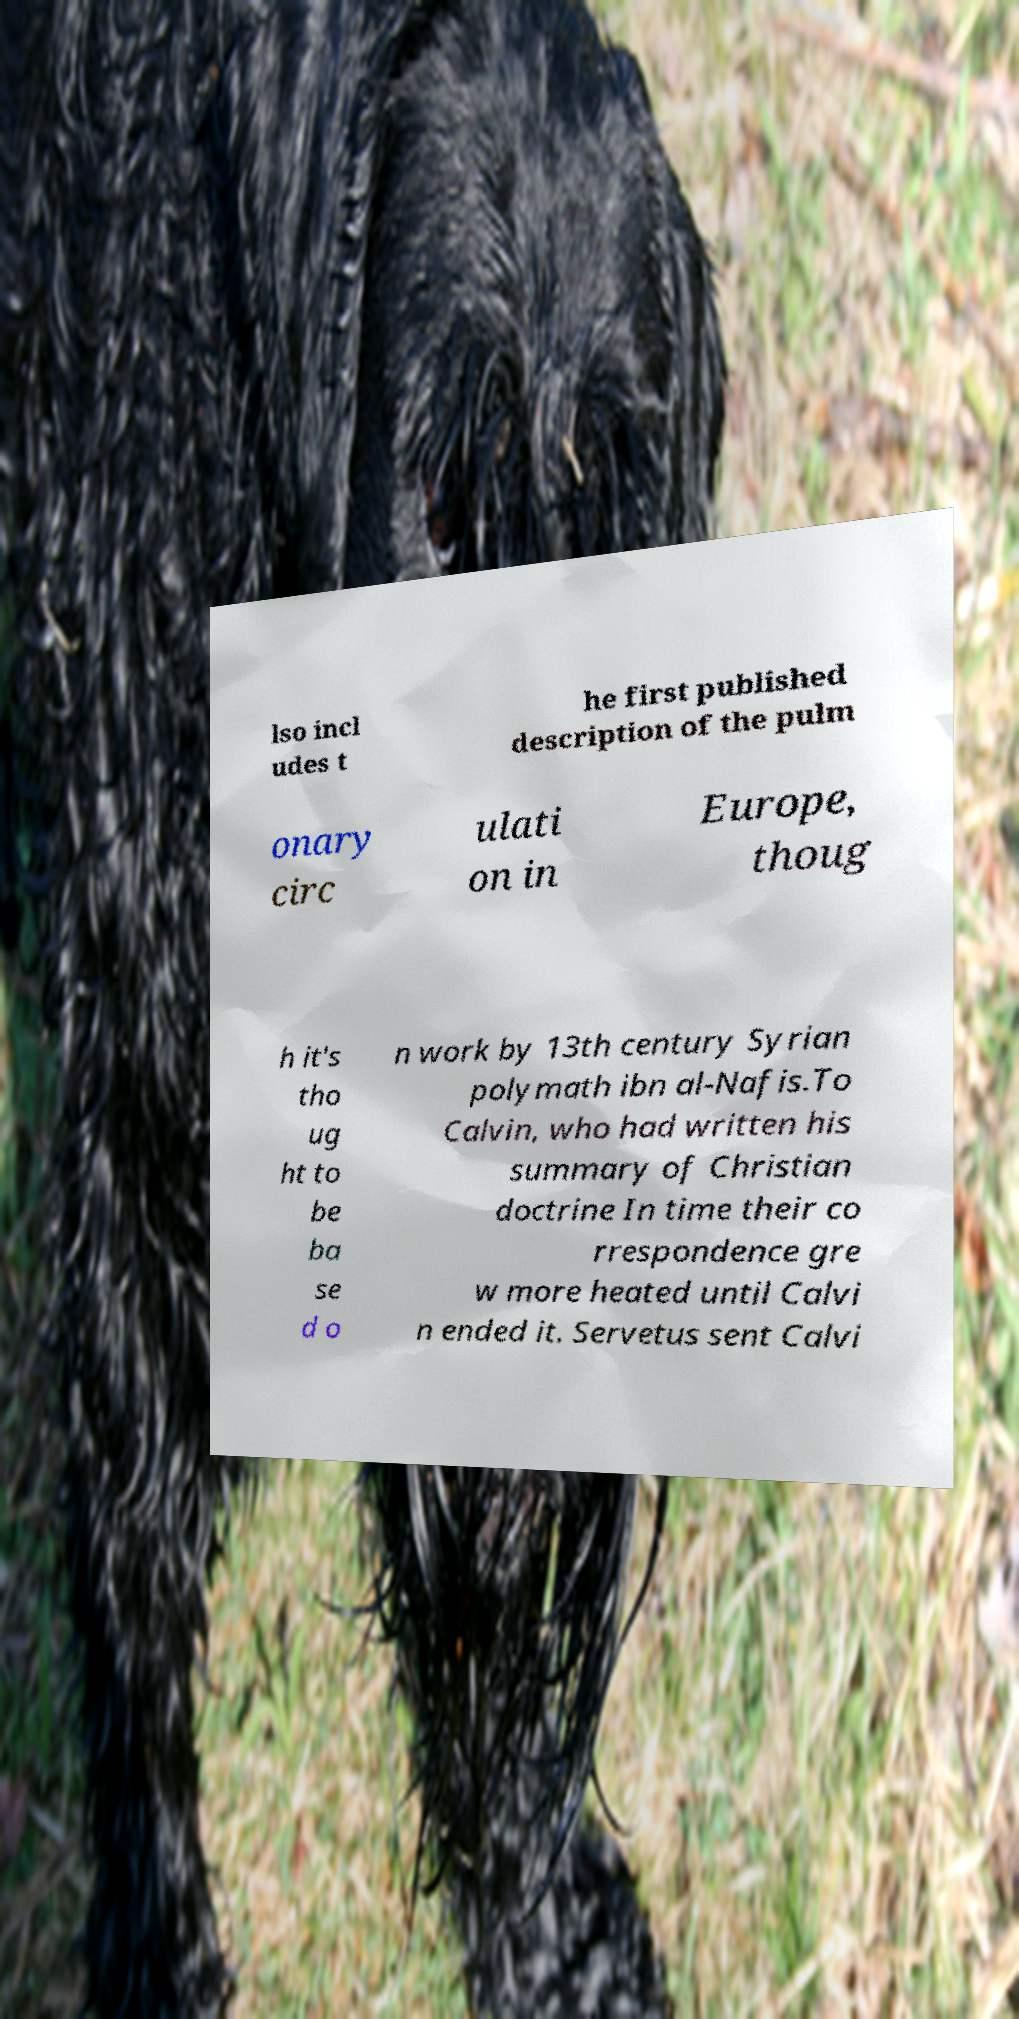Can you accurately transcribe the text from the provided image for me? lso incl udes t he first published description of the pulm onary circ ulati on in Europe, thoug h it's tho ug ht to be ba se d o n work by 13th century Syrian polymath ibn al-Nafis.To Calvin, who had written his summary of Christian doctrine In time their co rrespondence gre w more heated until Calvi n ended it. Servetus sent Calvi 